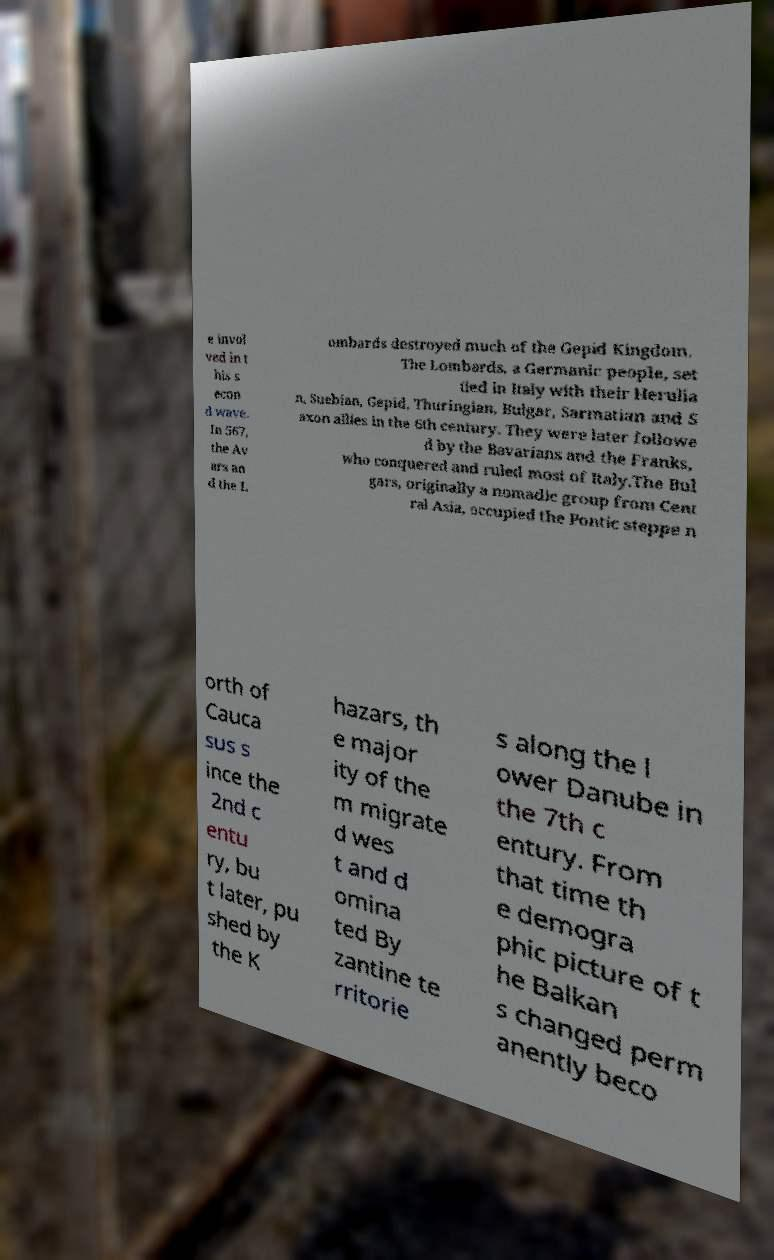Can you read and provide the text displayed in the image?This photo seems to have some interesting text. Can you extract and type it out for me? e invol ved in t his s econ d wave. In 567, the Av ars an d the L ombards destroyed much of the Gepid Kingdom. The Lombards, a Germanic people, set tled in Italy with their Herulia n, Suebian, Gepid, Thuringian, Bulgar, Sarmatian and S axon allies in the 6th century. They were later followe d by the Bavarians and the Franks, who conquered and ruled most of Italy.The Bul gars, originally a nomadic group from Cent ral Asia, occupied the Pontic steppe n orth of Cauca sus s ince the 2nd c entu ry, bu t later, pu shed by the K hazars, th e major ity of the m migrate d wes t and d omina ted By zantine te rritorie s along the l ower Danube in the 7th c entury. From that time th e demogra phic picture of t he Balkan s changed perm anently beco 